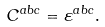<formula> <loc_0><loc_0><loc_500><loc_500>C ^ { a b c } = \varepsilon ^ { a b c } .</formula> 